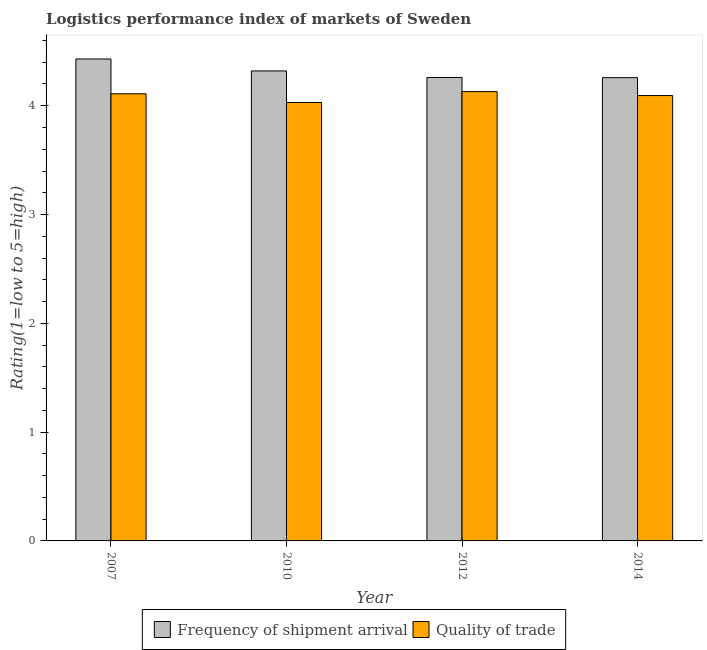How many different coloured bars are there?
Keep it short and to the point. 2. How many groups of bars are there?
Provide a short and direct response. 4. What is the label of the 2nd group of bars from the left?
Provide a succinct answer. 2010. In how many cases, is the number of bars for a given year not equal to the number of legend labels?
Make the answer very short. 0. What is the lpi of frequency of shipment arrival in 2007?
Make the answer very short. 4.43. Across all years, what is the maximum lpi quality of trade?
Offer a very short reply. 4.13. Across all years, what is the minimum lpi of frequency of shipment arrival?
Keep it short and to the point. 4.26. In which year was the lpi of frequency of shipment arrival maximum?
Offer a terse response. 2007. What is the total lpi quality of trade in the graph?
Keep it short and to the point. 16.36. What is the difference between the lpi quality of trade in 2012 and that in 2014?
Give a very brief answer. 0.04. What is the difference between the lpi quality of trade in 2012 and the lpi of frequency of shipment arrival in 2010?
Keep it short and to the point. 0.1. What is the average lpi of frequency of shipment arrival per year?
Your answer should be very brief. 4.32. In the year 2014, what is the difference between the lpi of frequency of shipment arrival and lpi quality of trade?
Provide a succinct answer. 0. What is the ratio of the lpi of frequency of shipment arrival in 2010 to that in 2014?
Provide a short and direct response. 1.01. Is the difference between the lpi quality of trade in 2010 and 2014 greater than the difference between the lpi of frequency of shipment arrival in 2010 and 2014?
Give a very brief answer. No. What is the difference between the highest and the second highest lpi quality of trade?
Your answer should be very brief. 0.02. What is the difference between the highest and the lowest lpi of frequency of shipment arrival?
Your response must be concise. 0.17. In how many years, is the lpi of frequency of shipment arrival greater than the average lpi of frequency of shipment arrival taken over all years?
Offer a terse response. 2. Is the sum of the lpi quality of trade in 2010 and 2014 greater than the maximum lpi of frequency of shipment arrival across all years?
Your answer should be compact. Yes. What does the 1st bar from the left in 2014 represents?
Offer a terse response. Frequency of shipment arrival. What does the 1st bar from the right in 2010 represents?
Make the answer very short. Quality of trade. How many years are there in the graph?
Offer a terse response. 4. Where does the legend appear in the graph?
Provide a succinct answer. Bottom center. How many legend labels are there?
Your answer should be very brief. 2. What is the title of the graph?
Your answer should be very brief. Logistics performance index of markets of Sweden. What is the label or title of the X-axis?
Provide a short and direct response. Year. What is the label or title of the Y-axis?
Your response must be concise. Rating(1=low to 5=high). What is the Rating(1=low to 5=high) in Frequency of shipment arrival in 2007?
Provide a succinct answer. 4.43. What is the Rating(1=low to 5=high) of Quality of trade in 2007?
Ensure brevity in your answer.  4.11. What is the Rating(1=low to 5=high) of Frequency of shipment arrival in 2010?
Offer a terse response. 4.32. What is the Rating(1=low to 5=high) of Quality of trade in 2010?
Your response must be concise. 4.03. What is the Rating(1=low to 5=high) in Frequency of shipment arrival in 2012?
Offer a terse response. 4.26. What is the Rating(1=low to 5=high) of Quality of trade in 2012?
Provide a short and direct response. 4.13. What is the Rating(1=low to 5=high) of Frequency of shipment arrival in 2014?
Keep it short and to the point. 4.26. What is the Rating(1=low to 5=high) in Quality of trade in 2014?
Keep it short and to the point. 4.09. Across all years, what is the maximum Rating(1=low to 5=high) of Frequency of shipment arrival?
Make the answer very short. 4.43. Across all years, what is the maximum Rating(1=low to 5=high) of Quality of trade?
Your response must be concise. 4.13. Across all years, what is the minimum Rating(1=low to 5=high) in Frequency of shipment arrival?
Provide a succinct answer. 4.26. Across all years, what is the minimum Rating(1=low to 5=high) of Quality of trade?
Offer a very short reply. 4.03. What is the total Rating(1=low to 5=high) of Frequency of shipment arrival in the graph?
Keep it short and to the point. 17.27. What is the total Rating(1=low to 5=high) of Quality of trade in the graph?
Make the answer very short. 16.36. What is the difference between the Rating(1=low to 5=high) of Frequency of shipment arrival in 2007 and that in 2010?
Offer a very short reply. 0.11. What is the difference between the Rating(1=low to 5=high) in Quality of trade in 2007 and that in 2010?
Provide a succinct answer. 0.08. What is the difference between the Rating(1=low to 5=high) of Frequency of shipment arrival in 2007 and that in 2012?
Make the answer very short. 0.17. What is the difference between the Rating(1=low to 5=high) of Quality of trade in 2007 and that in 2012?
Your answer should be compact. -0.02. What is the difference between the Rating(1=low to 5=high) of Frequency of shipment arrival in 2007 and that in 2014?
Ensure brevity in your answer.  0.17. What is the difference between the Rating(1=low to 5=high) of Quality of trade in 2007 and that in 2014?
Offer a very short reply. 0.02. What is the difference between the Rating(1=low to 5=high) in Frequency of shipment arrival in 2010 and that in 2012?
Offer a very short reply. 0.06. What is the difference between the Rating(1=low to 5=high) in Frequency of shipment arrival in 2010 and that in 2014?
Make the answer very short. 0.06. What is the difference between the Rating(1=low to 5=high) in Quality of trade in 2010 and that in 2014?
Your answer should be compact. -0.06. What is the difference between the Rating(1=low to 5=high) of Frequency of shipment arrival in 2012 and that in 2014?
Give a very brief answer. 0. What is the difference between the Rating(1=low to 5=high) in Quality of trade in 2012 and that in 2014?
Make the answer very short. 0.04. What is the difference between the Rating(1=low to 5=high) in Frequency of shipment arrival in 2007 and the Rating(1=low to 5=high) in Quality of trade in 2010?
Provide a succinct answer. 0.4. What is the difference between the Rating(1=low to 5=high) of Frequency of shipment arrival in 2007 and the Rating(1=low to 5=high) of Quality of trade in 2012?
Your response must be concise. 0.3. What is the difference between the Rating(1=low to 5=high) of Frequency of shipment arrival in 2007 and the Rating(1=low to 5=high) of Quality of trade in 2014?
Keep it short and to the point. 0.34. What is the difference between the Rating(1=low to 5=high) of Frequency of shipment arrival in 2010 and the Rating(1=low to 5=high) of Quality of trade in 2012?
Offer a very short reply. 0.19. What is the difference between the Rating(1=low to 5=high) of Frequency of shipment arrival in 2010 and the Rating(1=low to 5=high) of Quality of trade in 2014?
Provide a short and direct response. 0.23. What is the difference between the Rating(1=low to 5=high) of Frequency of shipment arrival in 2012 and the Rating(1=low to 5=high) of Quality of trade in 2014?
Give a very brief answer. 0.17. What is the average Rating(1=low to 5=high) in Frequency of shipment arrival per year?
Keep it short and to the point. 4.32. What is the average Rating(1=low to 5=high) of Quality of trade per year?
Give a very brief answer. 4.09. In the year 2007, what is the difference between the Rating(1=low to 5=high) in Frequency of shipment arrival and Rating(1=low to 5=high) in Quality of trade?
Keep it short and to the point. 0.32. In the year 2010, what is the difference between the Rating(1=low to 5=high) in Frequency of shipment arrival and Rating(1=low to 5=high) in Quality of trade?
Offer a terse response. 0.29. In the year 2012, what is the difference between the Rating(1=low to 5=high) of Frequency of shipment arrival and Rating(1=low to 5=high) of Quality of trade?
Make the answer very short. 0.13. In the year 2014, what is the difference between the Rating(1=low to 5=high) in Frequency of shipment arrival and Rating(1=low to 5=high) in Quality of trade?
Your response must be concise. 0.16. What is the ratio of the Rating(1=low to 5=high) in Frequency of shipment arrival in 2007 to that in 2010?
Provide a short and direct response. 1.03. What is the ratio of the Rating(1=low to 5=high) of Quality of trade in 2007 to that in 2010?
Offer a terse response. 1.02. What is the ratio of the Rating(1=low to 5=high) of Frequency of shipment arrival in 2007 to that in 2012?
Ensure brevity in your answer.  1.04. What is the ratio of the Rating(1=low to 5=high) of Quality of trade in 2007 to that in 2012?
Offer a very short reply. 1. What is the ratio of the Rating(1=low to 5=high) of Frequency of shipment arrival in 2007 to that in 2014?
Your response must be concise. 1.04. What is the ratio of the Rating(1=low to 5=high) in Quality of trade in 2007 to that in 2014?
Make the answer very short. 1. What is the ratio of the Rating(1=low to 5=high) in Frequency of shipment arrival in 2010 to that in 2012?
Your answer should be compact. 1.01. What is the ratio of the Rating(1=low to 5=high) in Quality of trade in 2010 to that in 2012?
Ensure brevity in your answer.  0.98. What is the ratio of the Rating(1=low to 5=high) in Frequency of shipment arrival in 2010 to that in 2014?
Offer a terse response. 1.01. What is the ratio of the Rating(1=low to 5=high) in Quality of trade in 2010 to that in 2014?
Offer a very short reply. 0.98. What is the ratio of the Rating(1=low to 5=high) in Frequency of shipment arrival in 2012 to that in 2014?
Your answer should be very brief. 1. What is the ratio of the Rating(1=low to 5=high) in Quality of trade in 2012 to that in 2014?
Offer a terse response. 1.01. What is the difference between the highest and the second highest Rating(1=low to 5=high) in Frequency of shipment arrival?
Offer a very short reply. 0.11. What is the difference between the highest and the lowest Rating(1=low to 5=high) in Frequency of shipment arrival?
Offer a terse response. 0.17. What is the difference between the highest and the lowest Rating(1=low to 5=high) in Quality of trade?
Offer a very short reply. 0.1. 